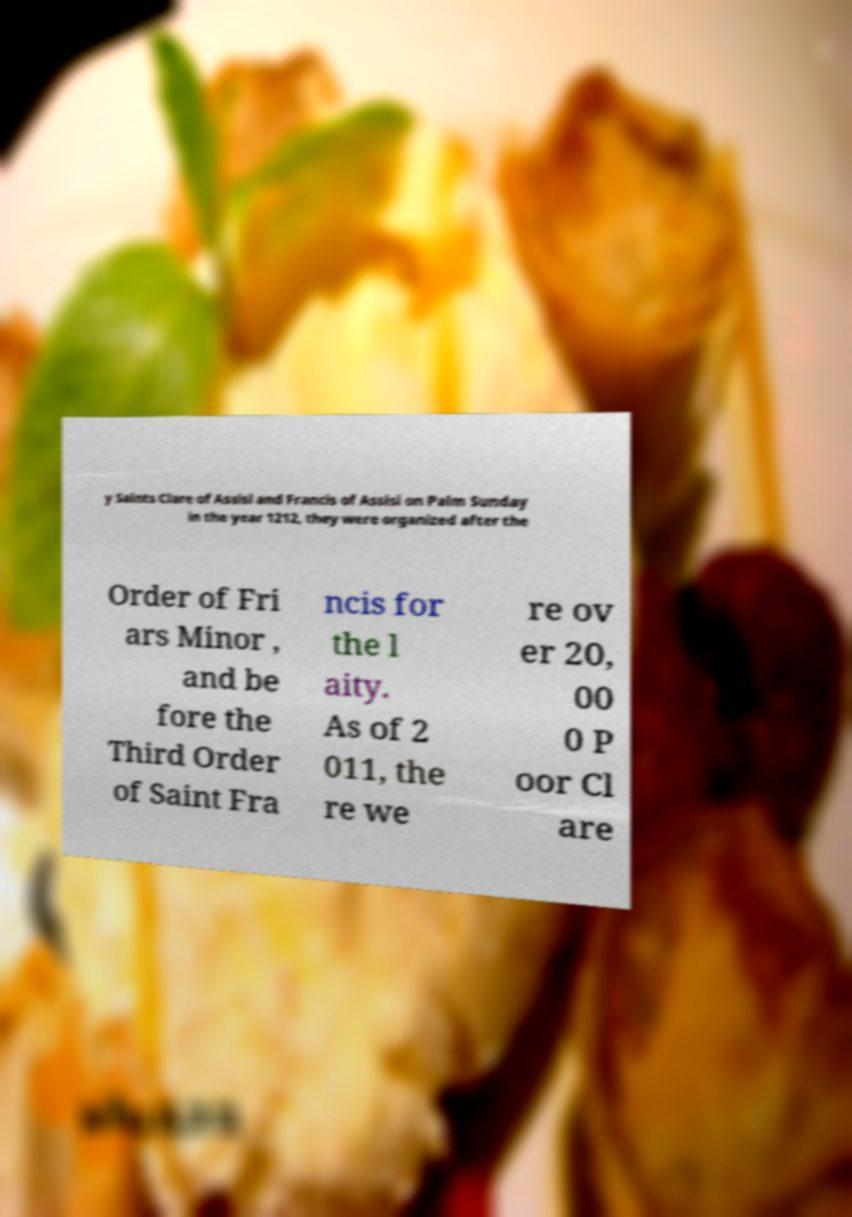Please read and relay the text visible in this image. What does it say? y Saints Clare of Assisi and Francis of Assisi on Palm Sunday in the year 1212, they were organized after the Order of Fri ars Minor , and be fore the Third Order of Saint Fra ncis for the l aity. As of 2 011, the re we re ov er 20, 00 0 P oor Cl are 